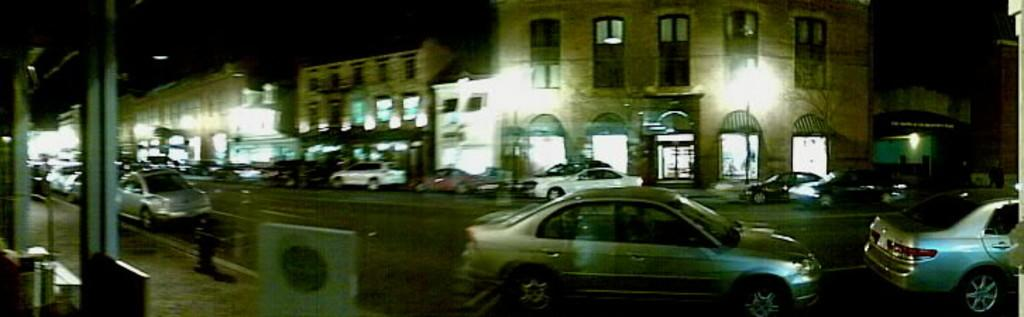What object is visible in the image that might be used for drinking? There is a glass in the image that might be used for drinking. What type of surface is visible behind the glass? There is a pavement visible behind the glass. What can be seen in the distance in the image? There are buildings in the background of the image. What is illuminated in the image? Lights are present in the image. What type of vehicles can be seen on the road in the image? Cars are visible on the road in the image. What is located on the left side of the image? There are objects on the left side of the image. What type of parent is depicted in the image? There is no parent depicted in the image; it features a glass, pavement, buildings, lights, cars, and objects on the left side. What type of weather condition is present in the image? The text does not mention any specific weather conditions, such as sleet. 